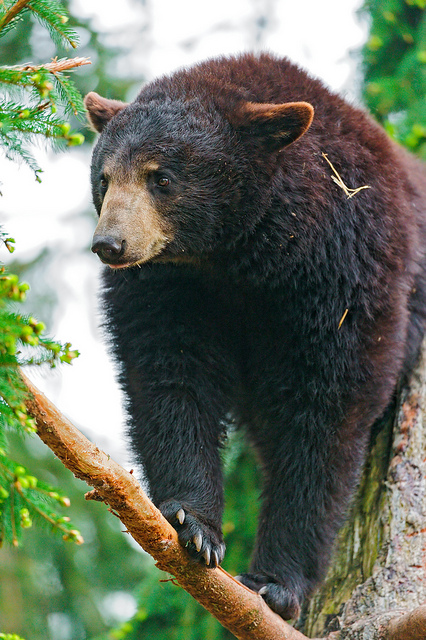What are the possible reasons for the bear climbing this tree and standing on a branch? There are several reasons why this bear may have climbed the tree and is standing on a branch. Firstly, bears often climb trees in search of food; they may find fruits, nuts, or even small animals to eat among the branches. Secondly, the bear could be seeking safety. For young bears in particular, trees provide a refuge from predators, such as larger aggressive bears or humans. Additionally, climbing might offer the bear an elevated vantage point to better survey its surroundings, allowing it to spot both opportunities and threats more effectively. Finally, bears are curious creatures, and this young bear might be exploring or playing in its environment, which is crucial for its development and learning about its habitat. This natural behavior helps bears become more adept at navigating and surviving in their territory. 